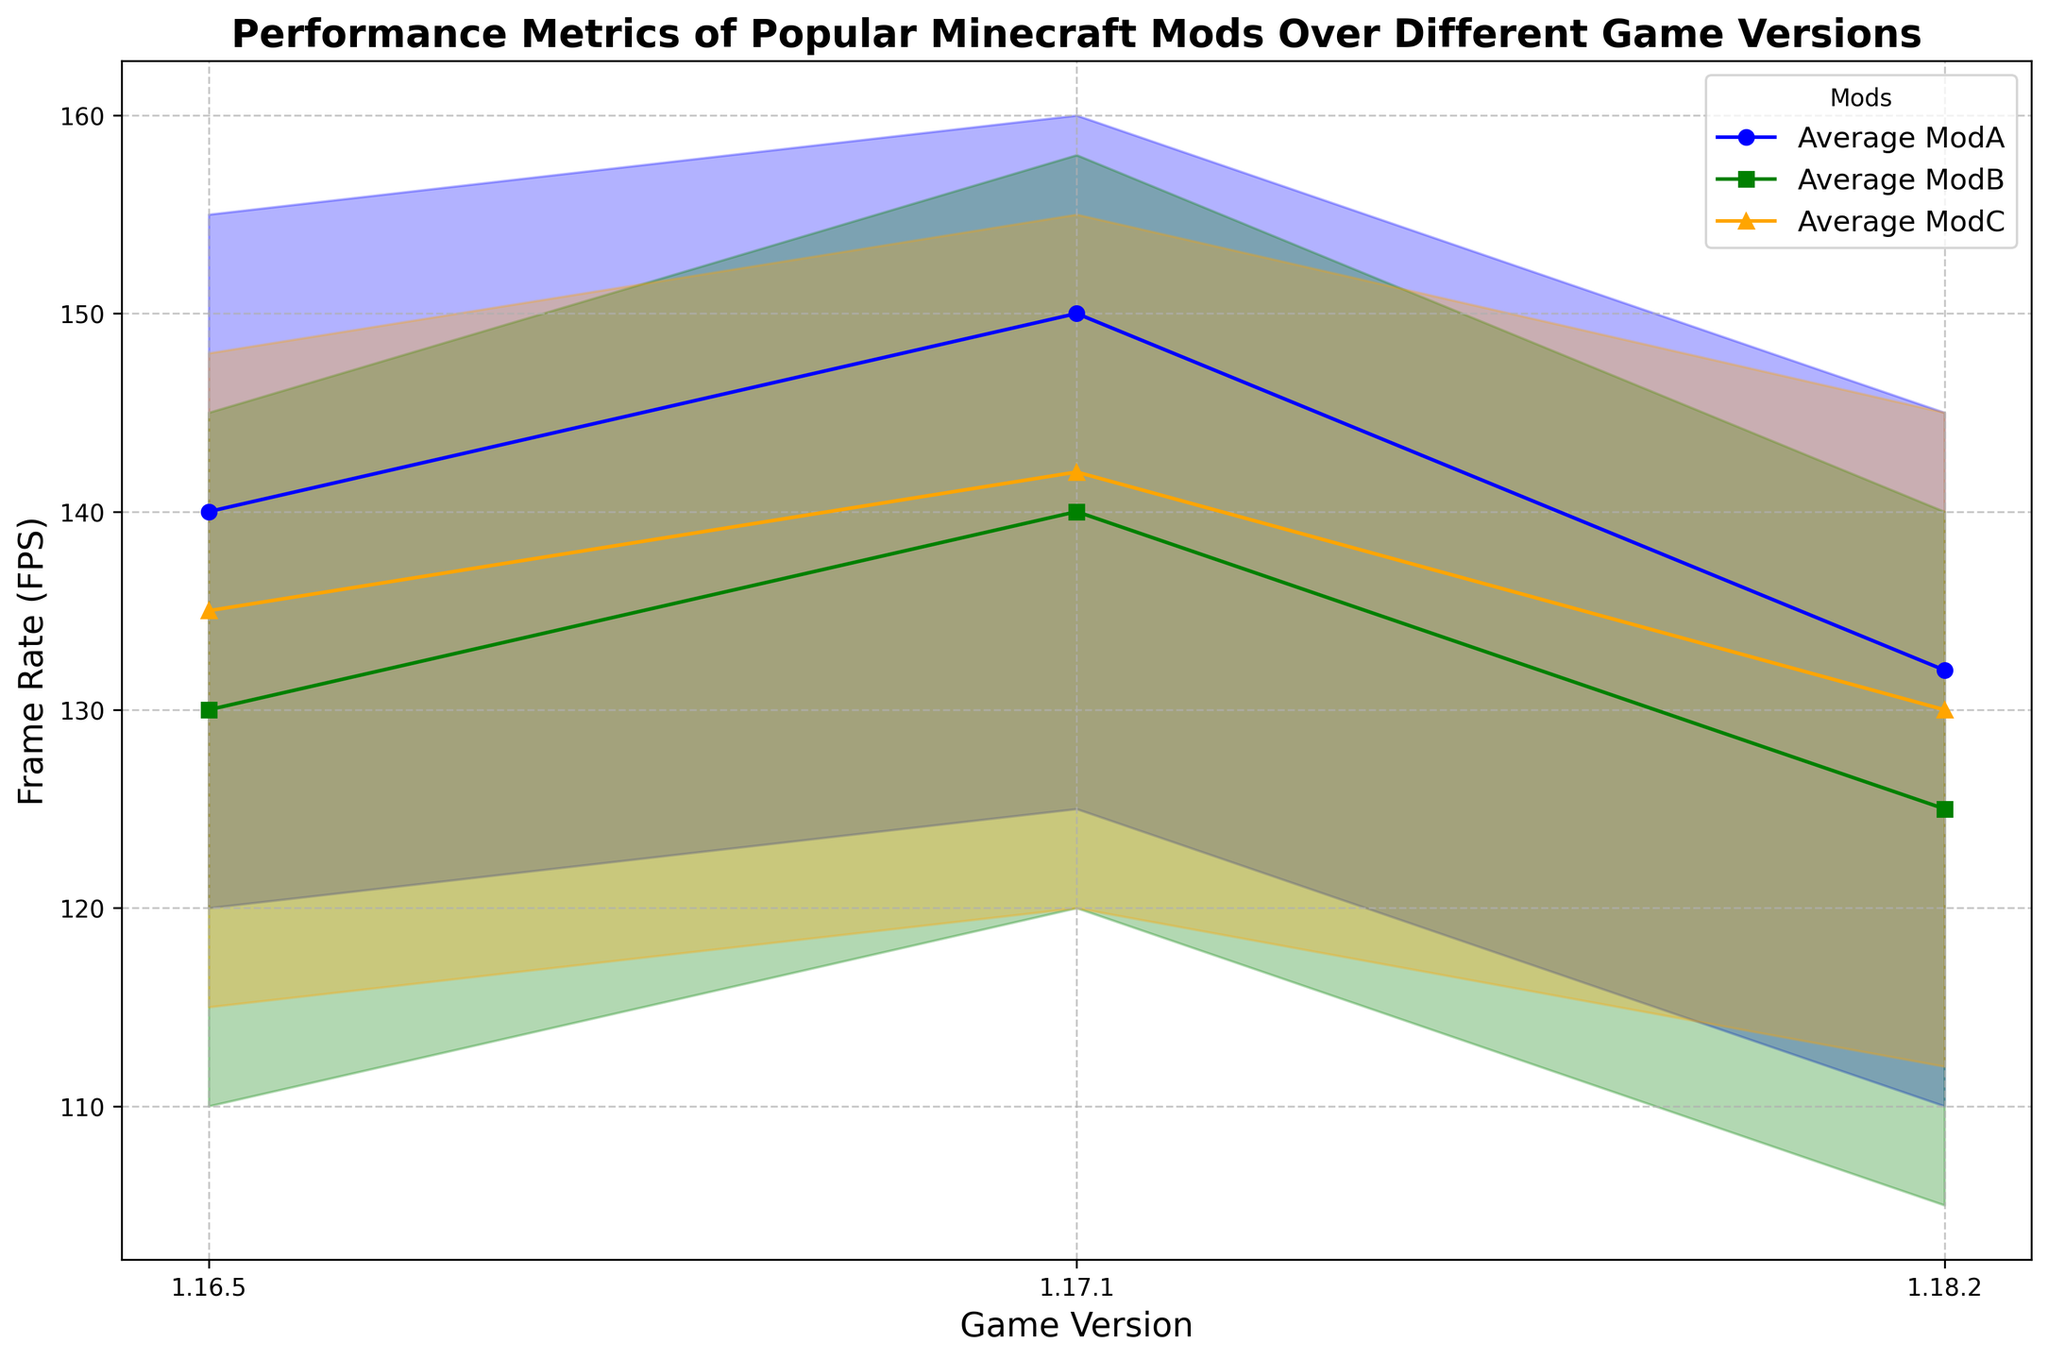What is the trend of the average frame rate for ModA over different game versions? The average frame rate for ModA starts at 140 FPS in version 1.16.5, increases to 150 FPS in version 1.17.1, and then decreases to 132 FPS in version 1.18.2. This shows an initial increase followed by a decrease.
Answer: Initial increase then decrease Which mod has the highest average frame rate in game version 1.17.1? By looking at the figure for game version 1.17.1, ModA has the highest average frame rate at 150 FPS, ModB has 140 FPS, and ModC has 142 FPS. Therefore, ModA has the highest average frame rate.
Answer: ModA How does the load time of ModB change across the different game versions? The load time for ModB starts at 25 seconds in version 1.16.5, increases to 27 seconds in version 1.17.1, and further increases to 30 seconds in version 1.18.2. The load time consistently increases.
Answer: Consistently increases What is the range of frame rates (min and max) for ModC in game version 1.17.1? In version 1.17.1 for ModC, the min frame rate is 120 FPS, and the max frame rate is 155 FPS. The range is from 120 to 155 FPS.
Answer: 120 to 155 FPS Which mod shows the largest decrease in average frame rate from version 1.17.1 to 1.18.2? ModA's average frame rate decreases from 150 FPS to 132 FPS (a decrease of 18 FPS), ModB's from 140 FPS to 125 FPS (15 FPS decrease), and ModC's from 142 FPS to 130 FPS (12 FPS decrease). ModA shows the largest decrease.
Answer: ModA Compare the maximum frame rates of all mods in game version 1.16.5. Which one is the highest? In version 1.16.5, the maximum frame rate for ModA is 155 FPS, for ModB it's 145 FPS, and for ModC it's 148 FPS. Therefore, ModA has the highest maximum frame rate.
Answer: ModA Between which two game versions does ModC show an improvement in both average frame rate and load time? ModC's average frame rate increases from 135 FPS in version 1.16.5 to 142 FPS in version 1.17.1, and the load time decreases from 28 seconds to 27 seconds. Therefore, the improvement in both metrics is between versions 1.16.5 and 1.17.1.
Answer: 1.16.5 and 1.17.1 What is the visual trend of the fill between lines for ModB across different game versions? For ModB, the min and max frame rates range is visually represented by fill between the lines. In version 1.16.5, the range is 110 to 145 FPS. In 1.17.1, it's 120 to 158 FPS. In 1.18.2, it's 105 to 140 FPS. The fill height increases from 1.16.5 to 1.17.1 and then decreases in 1.18.2.
Answer: Increases then decreases 